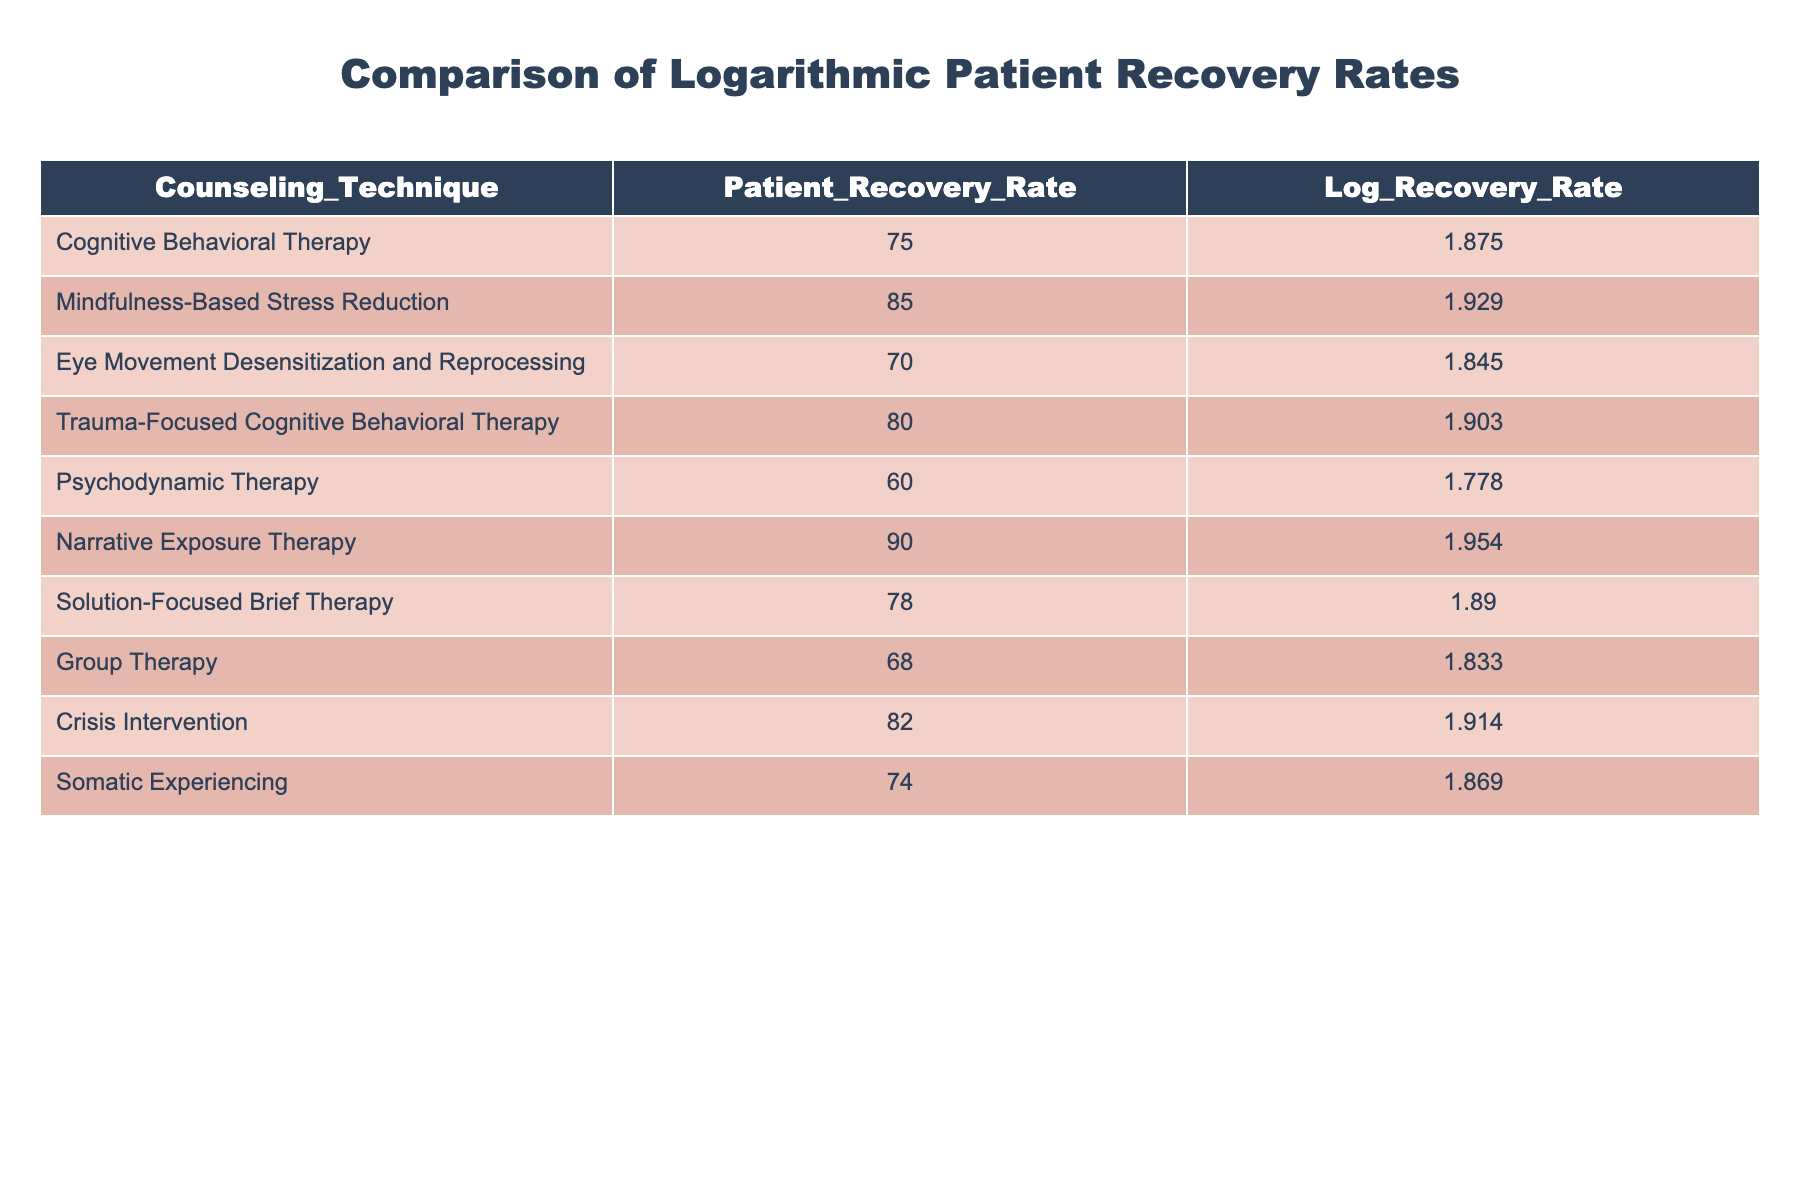What is the patient recovery rate for Mindfulness-Based Stress Reduction? The table shows that the patient recovery rate for Mindfulness-Based Stress Reduction is listed directly under the "Patient_Recovery_Rate" column.
Answer: 85 Which counseling technique has the lowest logarithmic recovery rate? By examining the "Log_Recovery_Rate" column, the technique with the lowest value is Psychodynamic Therapy, which has a value of 1.778.
Answer: Psychodynamic Therapy What is the difference between the recovery rates of Narrative Exposure Therapy and Crisis Intervention? To find the difference, subtract the recovery rate of Crisis Intervention (82) from that of Narrative Exposure Therapy (90). Thus, 90 - 82 = 8.
Answer: 8 What is the average patient recovery rate for the therapies listed? To find the average, sum all the patient recovery rates: 75 + 85 + 70 + 80 + 60 + 90 + 78 + 68 + 82 + 74 =  79.8 and divide by the total number of therapies (10). Thus, the average is 798/10 = 79.8.
Answer: 79.8 Is the recovery rate for Solution-Focused Brief Therapy higher than that for Eye Movement Desensitization and Reprocessing? The recovery rate for Solution-Focused Brief Therapy is 78, and for Eye Movement Desensitization and Reprocessing, it is 70. Since 78 is greater than 70, the statement is true.
Answer: Yes Which counseling technique has a logarithmic recovery rate greater than 1.9? Looking at the "Log_Recovery_Rate" column, the values greater than 1.9 are for Mindfulness-Based Stress Reduction (1.929), Trauma-Focused Cognitive Behavioral Therapy (1.903), Narrative Exposure Therapy (1.954), and Crisis Intervention (1.914).
Answer: Mindfulness-Based Stress Reduction, Trauma-Focused Cognitive Behavioral Therapy, Narrative Exposure Therapy, Crisis Intervention What is the total recovery rate of Group Therapy and Somatic Experiencing combined? To find the total, add the recovery rates for Group Therapy (68) and Somatic Experiencing (74). So, 68 + 74 = 142.
Answer: 142 Is it true that all techniques have recovery rates above 60? By reviewing the "Patient_Recovery_Rate" values, all are indeed above 60; the lowest rate is for Psychodynamic Therapy at 60, so the statement is true.
Answer: Yes What are the highest and lowest recovery rates in the data? The highest recovery rate is for Narrative Exposure Therapy (90), while the lowest is for Psychodynamic Therapy (60). Comparing these values confirms this statement.
Answer: Highest: 90, Lowest: 60 